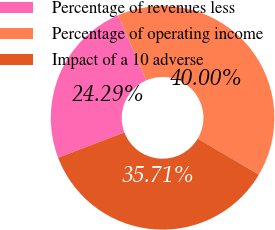Convert chart. <chart><loc_0><loc_0><loc_500><loc_500><pie_chart><fcel>Percentage of revenues less<fcel>Percentage of operating income<fcel>Impact of a 10 adverse<nl><fcel>24.29%<fcel>40.0%<fcel>35.71%<nl></chart> 